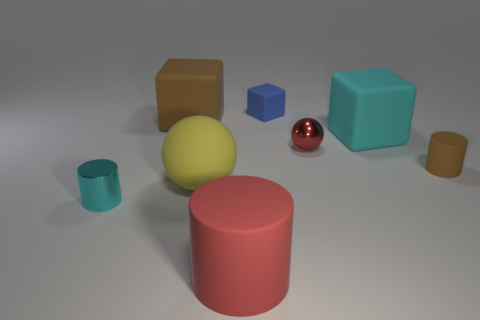What number of objects are in front of the yellow thing and to the right of the small cyan cylinder?
Keep it short and to the point. 1. How many large red objects are made of the same material as the yellow object?
Keep it short and to the point. 1. There is a cyan thing left of the brown matte object that is to the left of the red rubber cylinder; what is its size?
Your answer should be compact. Small. Is there another large blue rubber thing of the same shape as the blue rubber thing?
Provide a succinct answer. No. Is the size of the brown object that is on the right side of the blue matte object the same as the block that is in front of the large brown cube?
Your answer should be compact. No. Is the number of cylinders that are on the right side of the tiny blue rubber block less than the number of red objects that are left of the big brown thing?
Give a very brief answer. No. What is the material of the object that is the same color as the tiny metallic sphere?
Your answer should be compact. Rubber. There is a tiny matte object on the right side of the tiny red thing; what color is it?
Make the answer very short. Brown. Is the metal sphere the same color as the large cylinder?
Give a very brief answer. Yes. There is a metal object that is behind the small cylinder that is on the right side of the big cylinder; how many rubber cylinders are to the right of it?
Your response must be concise. 1. 